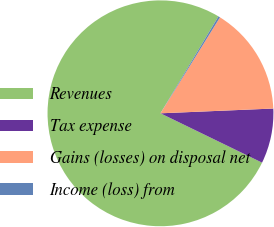<chart> <loc_0><loc_0><loc_500><loc_500><pie_chart><fcel>Revenues<fcel>Tax expense<fcel>Gains (losses) on disposal net<fcel>Income (loss) from<nl><fcel>76.38%<fcel>7.87%<fcel>15.49%<fcel>0.26%<nl></chart> 